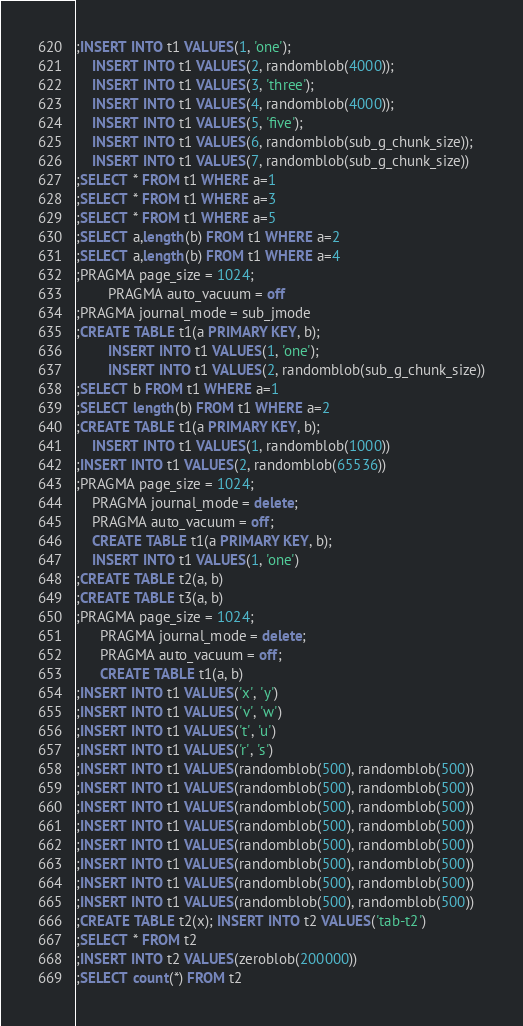Convert code to text. <code><loc_0><loc_0><loc_500><loc_500><_SQL_>;INSERT INTO t1 VALUES(1, 'one');
    INSERT INTO t1 VALUES(2, randomblob(4000));
    INSERT INTO t1 VALUES(3, 'three');
    INSERT INTO t1 VALUES(4, randomblob(4000));
    INSERT INTO t1 VALUES(5, 'five');
    INSERT INTO t1 VALUES(6, randomblob(sub_g_chunk_size));
    INSERT INTO t1 VALUES(7, randomblob(sub_g_chunk_size))
;SELECT * FROM t1 WHERE a=1
;SELECT * FROM t1 WHERE a=3
;SELECT * FROM t1 WHERE a=5
;SELECT a,length(b) FROM t1 WHERE a=2
;SELECT a,length(b) FROM t1 WHERE a=4
;PRAGMA page_size = 1024;
        PRAGMA auto_vacuum = off
;PRAGMA journal_mode = sub_jmode
;CREATE TABLE t1(a PRIMARY KEY, b);
        INSERT INTO t1 VALUES(1, 'one');
        INSERT INTO t1 VALUES(2, randomblob(sub_g_chunk_size))
;SELECT b FROM t1 WHERE a=1
;SELECT length(b) FROM t1 WHERE a=2
;CREATE TABLE t1(a PRIMARY KEY, b);
    INSERT INTO t1 VALUES(1, randomblob(1000))
;INSERT INTO t1 VALUES(2, randomblob(65536))
;PRAGMA page_size = 1024;
    PRAGMA journal_mode = delete;
    PRAGMA auto_vacuum = off;
    CREATE TABLE t1(a PRIMARY KEY, b);
    INSERT INTO t1 VALUES(1, 'one')
;CREATE TABLE t2(a, b)
;CREATE TABLE t3(a, b)
;PRAGMA page_size = 1024;
      PRAGMA journal_mode = delete;
      PRAGMA auto_vacuum = off;
      CREATE TABLE t1(a, b)
;INSERT INTO t1 VALUES('x', 'y')
;INSERT INTO t1 VALUES('v', 'w')
;INSERT INTO t1 VALUES('t', 'u')
;INSERT INTO t1 VALUES('r', 's')
;INSERT INTO t1 VALUES(randomblob(500), randomblob(500))
;INSERT INTO t1 VALUES(randomblob(500), randomblob(500))
;INSERT INTO t1 VALUES(randomblob(500), randomblob(500))
;INSERT INTO t1 VALUES(randomblob(500), randomblob(500))
;INSERT INTO t1 VALUES(randomblob(500), randomblob(500))
;INSERT INTO t1 VALUES(randomblob(500), randomblob(500))
;INSERT INTO t1 VALUES(randomblob(500), randomblob(500))
;INSERT INTO t1 VALUES(randomblob(500), randomblob(500))
;CREATE TABLE t2(x); INSERT INTO t2 VALUES('tab-t2')
;SELECT * FROM t2
;INSERT INTO t2 VALUES(zeroblob(200000))
;SELECT count(*) FROM t2</code> 